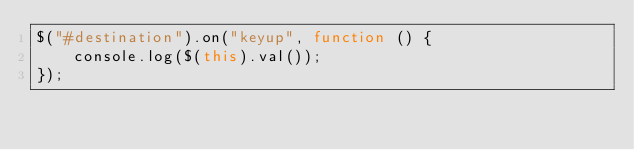Convert code to text. <code><loc_0><loc_0><loc_500><loc_500><_JavaScript_>$("#destination").on("keyup", function () { 
    console.log($(this).val());
});</code> 